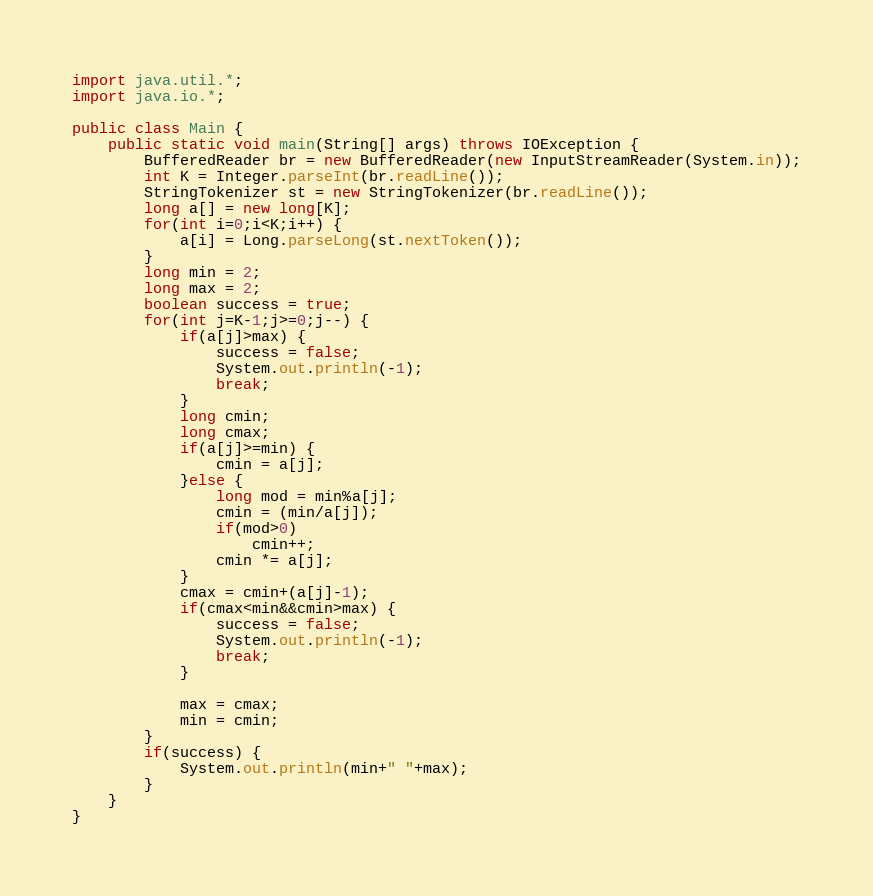Convert code to text. <code><loc_0><loc_0><loc_500><loc_500><_Java_>import java.util.*;
import java.io.*;

public class Main {
	public static void main(String[] args) throws IOException {
		BufferedReader br = new BufferedReader(new InputStreamReader(System.in));
		int K = Integer.parseInt(br.readLine());
		StringTokenizer st = new StringTokenizer(br.readLine());
		long a[] = new long[K];
		for(int i=0;i<K;i++) {
			a[i] = Long.parseLong(st.nextToken());
		}
		long min = 2;
		long max = 2;
		boolean success = true;
		for(int j=K-1;j>=0;j--) {
			if(a[j]>max) {
				success = false;
				System.out.println(-1);
				break;
			}
			long cmin;
			long cmax;
			if(a[j]>=min) {
				cmin = a[j];
			}else {
				long mod = min%a[j];
				cmin = (min/a[j]);
				if(mod>0)
					cmin++;
				cmin *= a[j];
			}
			cmax = cmin+(a[j]-1);
			if(cmax<min&&cmin>max) {
				success = false;
				System.out.println(-1);
				break;
			}
			
			max = cmax;
			min = cmin;
		}
		if(success) {
			System.out.println(min+" "+max);
		}
	}
}
</code> 